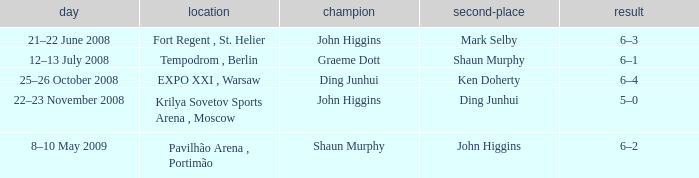When was the match that had Shaun Murphy as runner-up? 12–13 July 2008. 